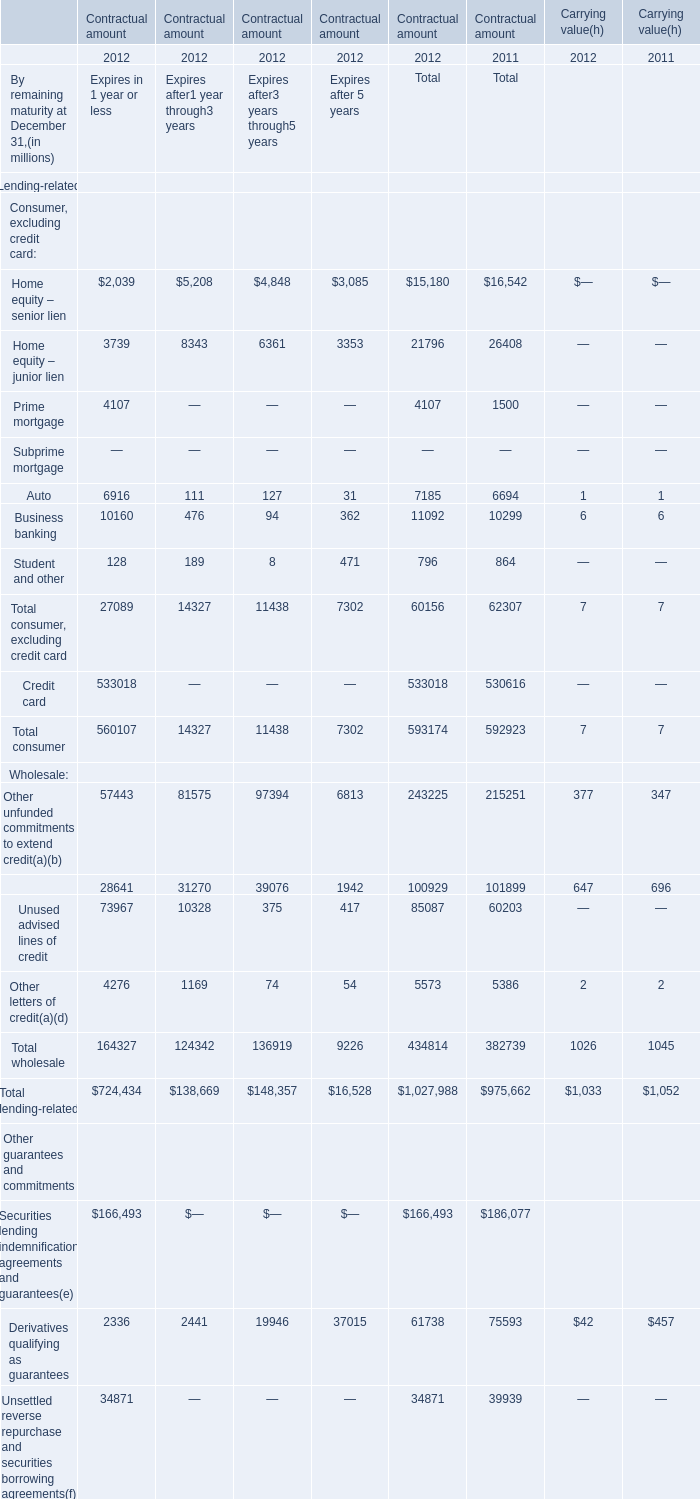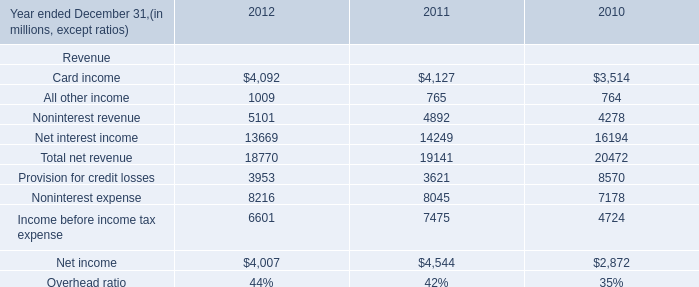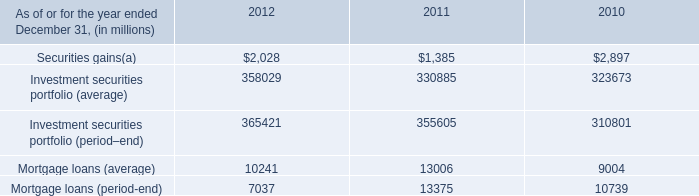If Home equity – senior lien develops with the same increasing rate in 2012, what will it reach in 2013? (in million) 
Computations: (15180 * (1 + ((15180 - 16542) / 16542)))
Answer: 13930.14146. 